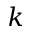<formula> <loc_0><loc_0><loc_500><loc_500>k</formula> 